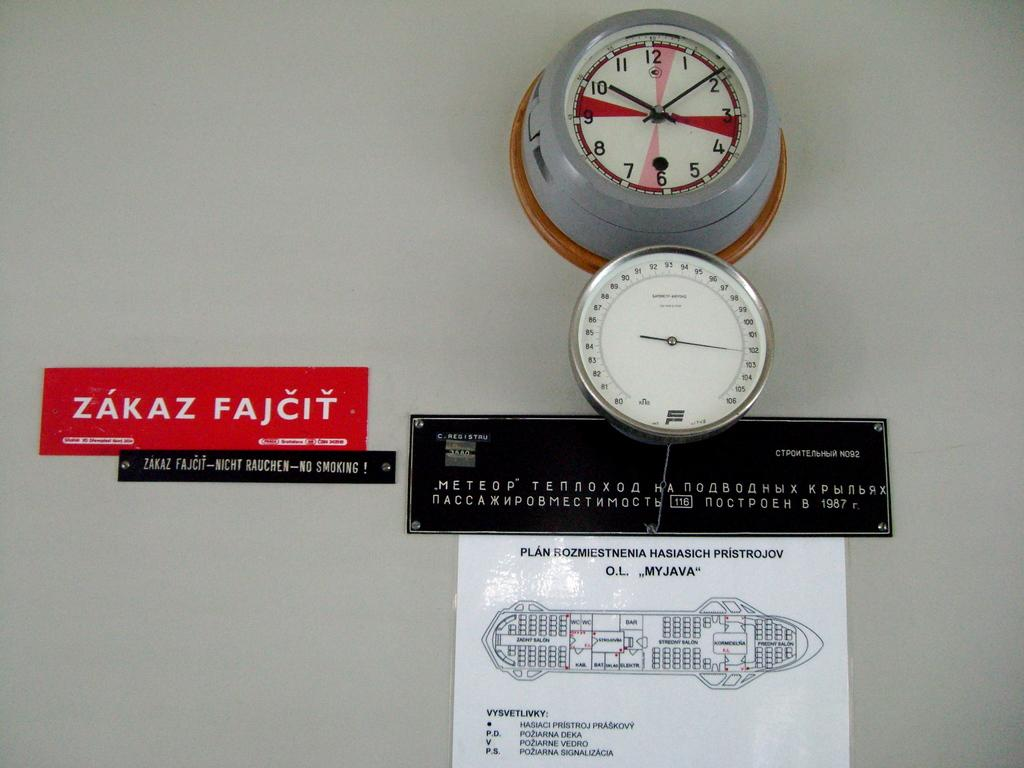Provide a one-sentence caption for the provided image. a zakaz sign that is on the wall. 